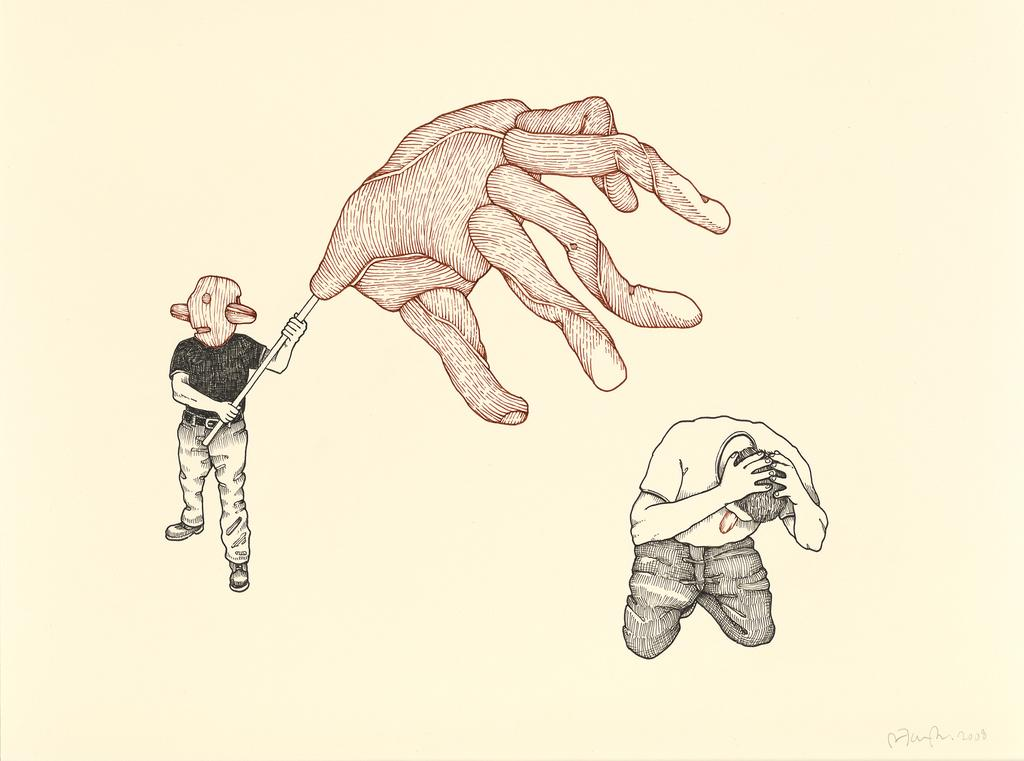What is the main subject of the image? The image contains a sketch. How many people are depicted in the sketch? There are two persons in the sketch. What is one of the persons doing in the sketch? One of the persons is holding an object. What color is the background of the image? The background of the image is white. What type of cork can be seen in the ear of one of the persons in the image? There is no cork or ear present in the image; it contains a sketch of two persons, and neither of them has a cork in their ear. 